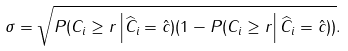Convert formula to latex. <formula><loc_0><loc_0><loc_500><loc_500>\sigma = \sqrt { P ( C _ { i } \geq r \left | \widehat { C } _ { i } = \hat { c } ) ( 1 - P ( C _ { i } \geq r \right | \widehat { C } _ { i } = \hat { c } ) ) } .</formula> 